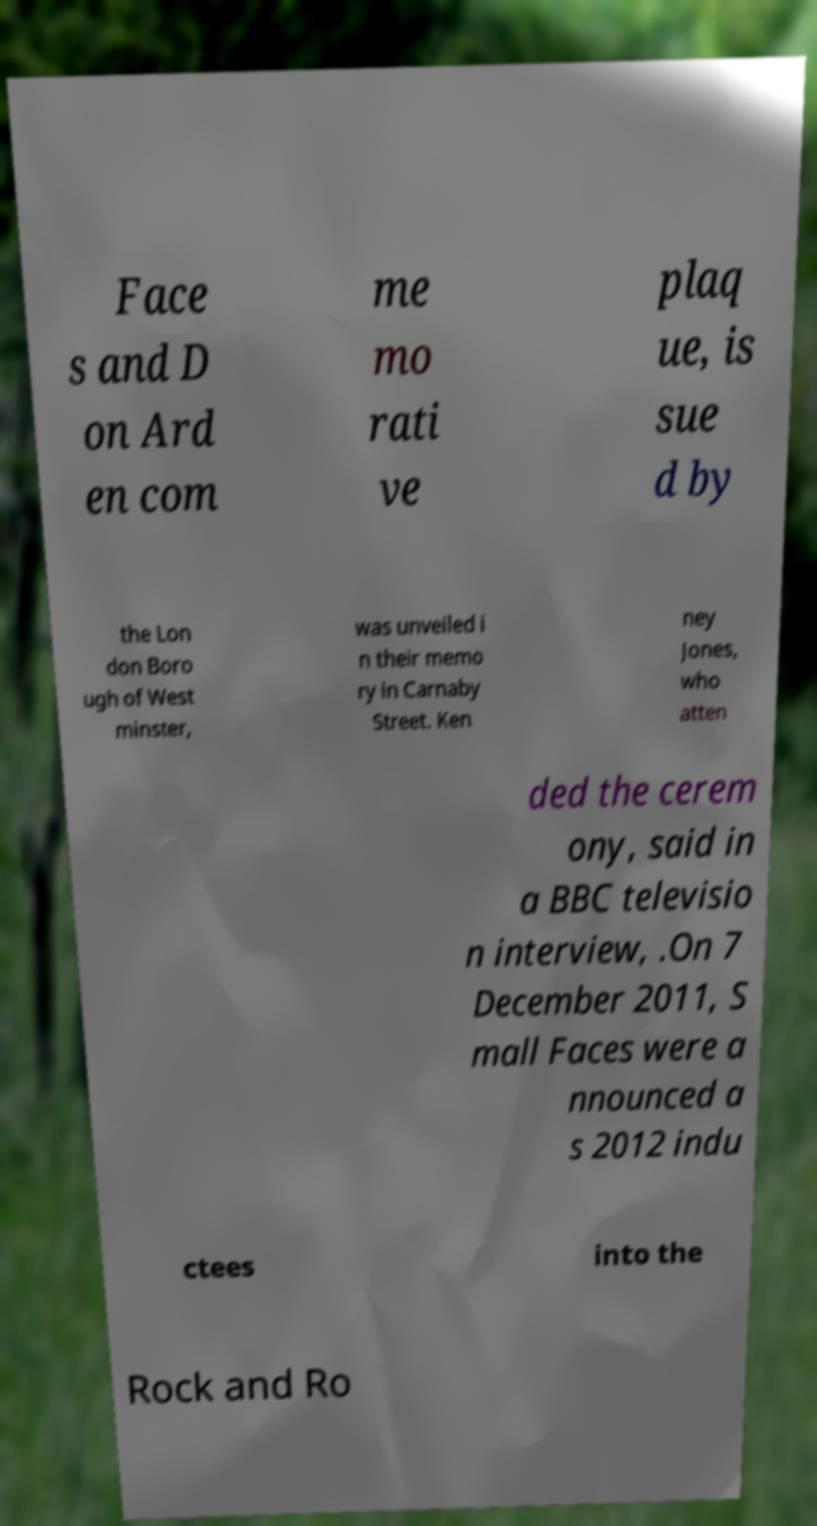Could you extract and type out the text from this image? Face s and D on Ard en com me mo rati ve plaq ue, is sue d by the Lon don Boro ugh of West minster, was unveiled i n their memo ry in Carnaby Street. Ken ney Jones, who atten ded the cerem ony, said in a BBC televisio n interview, .On 7 December 2011, S mall Faces were a nnounced a s 2012 indu ctees into the Rock and Ro 